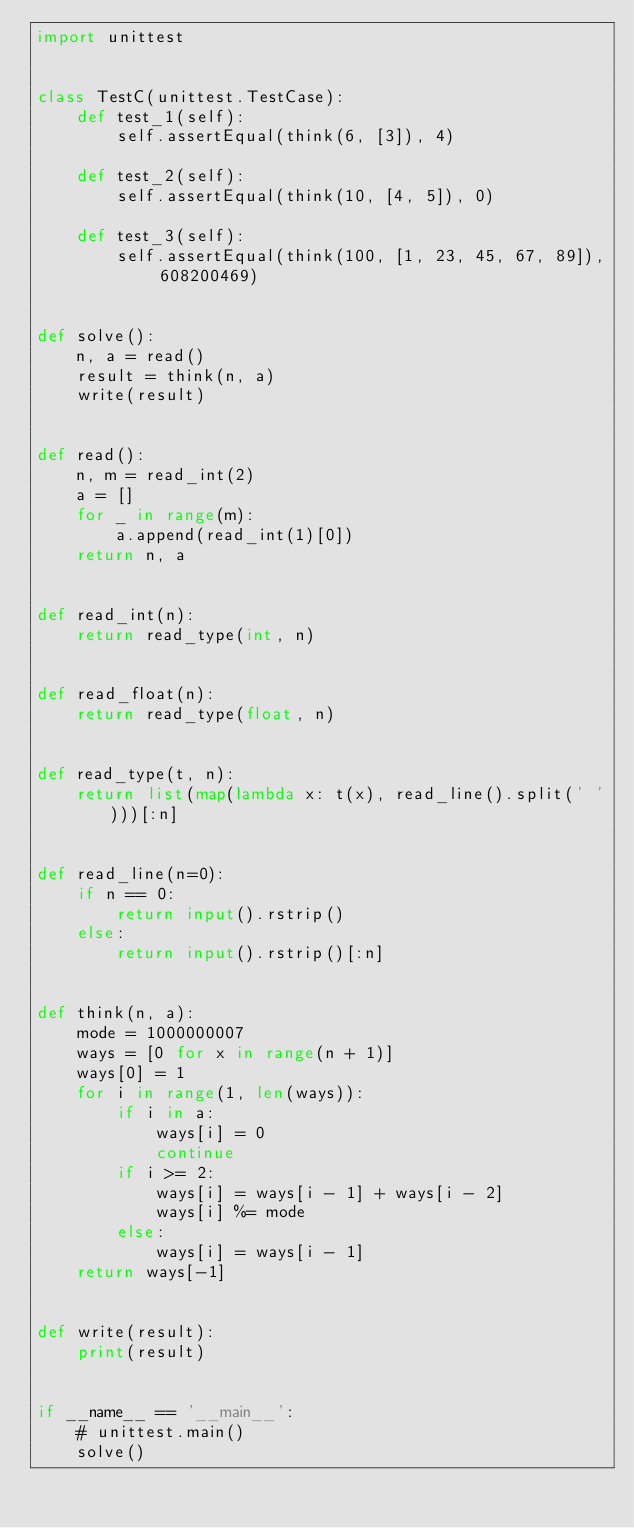Convert code to text. <code><loc_0><loc_0><loc_500><loc_500><_Python_>import unittest


class TestC(unittest.TestCase):
    def test_1(self):
        self.assertEqual(think(6, [3]), 4)

    def test_2(self):
        self.assertEqual(think(10, [4, 5]), 0)

    def test_3(self):
        self.assertEqual(think(100, [1, 23, 45, 67, 89]), 608200469)


def solve():
    n, a = read()
    result = think(n, a)
    write(result)


def read():
    n, m = read_int(2)
    a = []
    for _ in range(m):
        a.append(read_int(1)[0])
    return n, a


def read_int(n):
    return read_type(int, n)


def read_float(n):
    return read_type(float, n)


def read_type(t, n):
    return list(map(lambda x: t(x), read_line().split(' ')))[:n]


def read_line(n=0):
    if n == 0:
        return input().rstrip()
    else:
        return input().rstrip()[:n]


def think(n, a):
    mode = 1000000007
    ways = [0 for x in range(n + 1)]
    ways[0] = 1
    for i in range(1, len(ways)):
        if i in a:
            ways[i] = 0
            continue
        if i >= 2:
            ways[i] = ways[i - 1] + ways[i - 2]
            ways[i] %= mode
        else:
            ways[i] = ways[i - 1]
    return ways[-1]


def write(result):
    print(result)


if __name__ == '__main__':
    # unittest.main()
    solve()</code> 